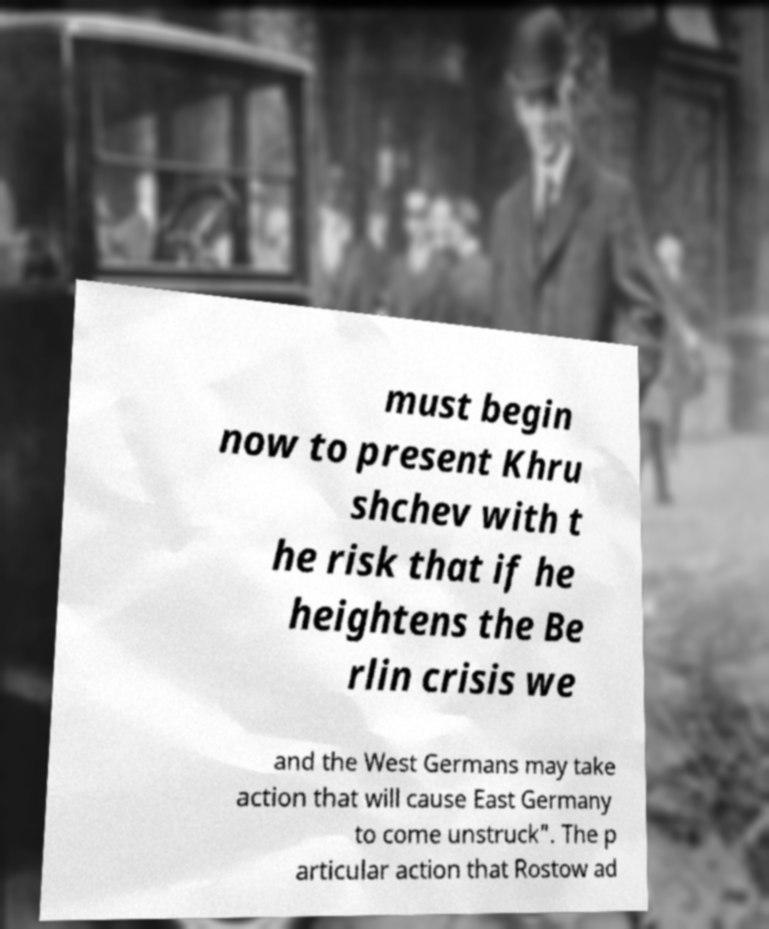I need the written content from this picture converted into text. Can you do that? must begin now to present Khru shchev with t he risk that if he heightens the Be rlin crisis we and the West Germans may take action that will cause East Germany to come unstruck". The p articular action that Rostow ad 